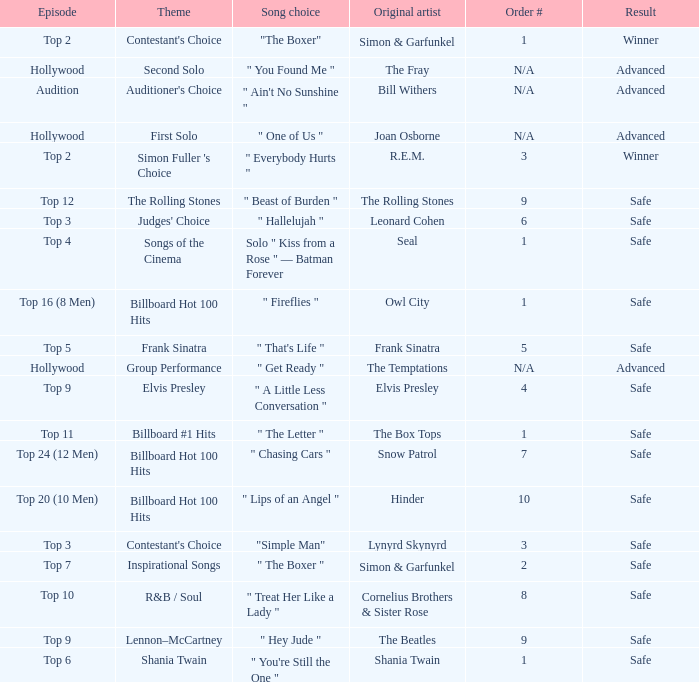In episode Top 16 (8 Men), what are the themes? Billboard Hot 100 Hits. Could you parse the entire table? {'header': ['Episode', 'Theme', 'Song choice', 'Original artist', 'Order #', 'Result'], 'rows': [['Top 2', "Contestant's Choice", '"The Boxer"', 'Simon & Garfunkel', '1', 'Winner'], ['Hollywood', 'Second Solo', '" You Found Me "', 'The Fray', 'N/A', 'Advanced'], ['Audition', "Auditioner's Choice", '" Ain\'t No Sunshine "', 'Bill Withers', 'N/A', 'Advanced'], ['Hollywood', 'First Solo', '" One of Us "', 'Joan Osborne', 'N/A', 'Advanced'], ['Top 2', "Simon Fuller 's Choice", '" Everybody Hurts "', 'R.E.M.', '3', 'Winner'], ['Top 12', 'The Rolling Stones', '" Beast of Burden "', 'The Rolling Stones', '9', 'Safe'], ['Top 3', "Judges' Choice", '" Hallelujah "', 'Leonard Cohen', '6', 'Safe'], ['Top 4', 'Songs of the Cinema', 'Solo " Kiss from a Rose " — Batman Forever', 'Seal', '1', 'Safe'], ['Top 16 (8 Men)', 'Billboard Hot 100 Hits', '" Fireflies "', 'Owl City', '1', 'Safe'], ['Top 5', 'Frank Sinatra', '" That\'s Life "', 'Frank Sinatra', '5', 'Safe'], ['Hollywood', 'Group Performance', '" Get Ready "', 'The Temptations', 'N/A', 'Advanced'], ['Top 9', 'Elvis Presley', '" A Little Less Conversation "', 'Elvis Presley', '4', 'Safe'], ['Top 11', 'Billboard #1 Hits', '" The Letter "', 'The Box Tops', '1', 'Safe'], ['Top 24 (12 Men)', 'Billboard Hot 100 Hits', '" Chasing Cars "', 'Snow Patrol', '7', 'Safe'], ['Top 20 (10 Men)', 'Billboard Hot 100 Hits', '" Lips of an Angel "', 'Hinder', '10', 'Safe'], ['Top 3', "Contestant's Choice", '"Simple Man"', 'Lynyrd Skynyrd', '3', 'Safe'], ['Top 7', 'Inspirational Songs', '" The Boxer "', 'Simon & Garfunkel', '2', 'Safe'], ['Top 10', 'R&B / Soul', '" Treat Her Like a Lady "', 'Cornelius Brothers & Sister Rose', '8', 'Safe'], ['Top 9', 'Lennon–McCartney', '" Hey Jude "', 'The Beatles', '9', 'Safe'], ['Top 6', 'Shania Twain', '" You\'re Still the One "', 'Shania Twain', '1', 'Safe']]} 